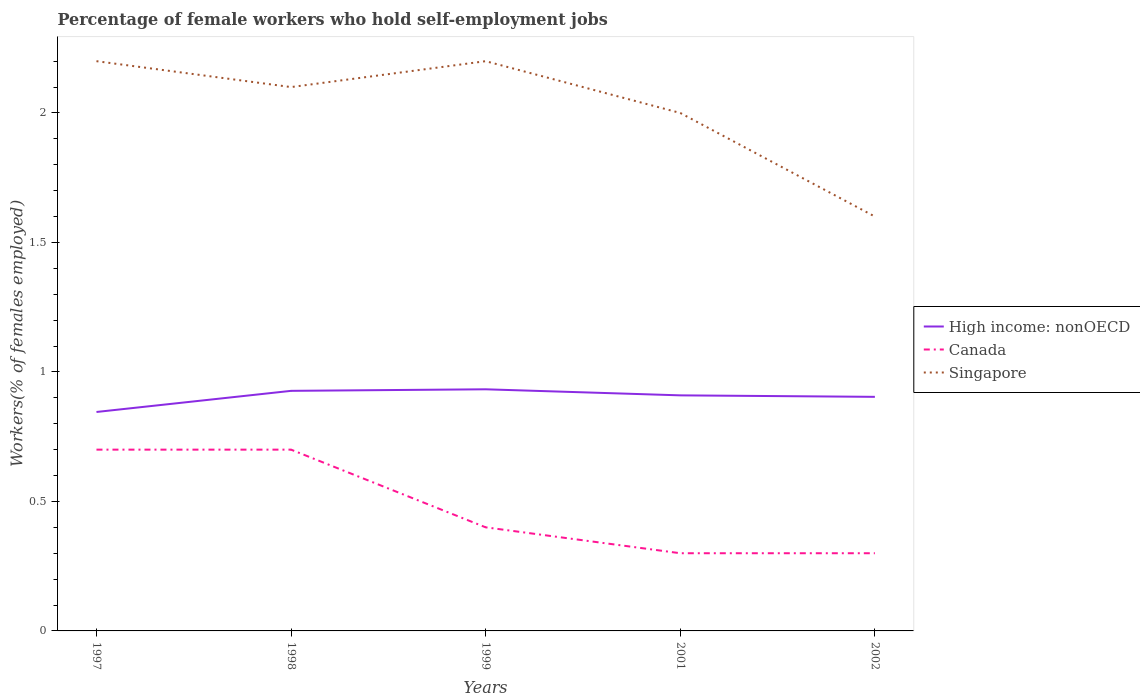How many different coloured lines are there?
Offer a terse response. 3. Does the line corresponding to Singapore intersect with the line corresponding to Canada?
Your answer should be compact. No. Across all years, what is the maximum percentage of self-employed female workers in High income: nonOECD?
Give a very brief answer. 0.85. What is the total percentage of self-employed female workers in Canada in the graph?
Give a very brief answer. 0.1. What is the difference between the highest and the second highest percentage of self-employed female workers in High income: nonOECD?
Your answer should be very brief. 0.09. How many lines are there?
Provide a succinct answer. 3. How many years are there in the graph?
Your answer should be very brief. 5. Does the graph contain grids?
Provide a succinct answer. No. Where does the legend appear in the graph?
Ensure brevity in your answer.  Center right. How many legend labels are there?
Offer a terse response. 3. What is the title of the graph?
Provide a succinct answer. Percentage of female workers who hold self-employment jobs. Does "Italy" appear as one of the legend labels in the graph?
Ensure brevity in your answer.  No. What is the label or title of the X-axis?
Provide a succinct answer. Years. What is the label or title of the Y-axis?
Your answer should be very brief. Workers(% of females employed). What is the Workers(% of females employed) in High income: nonOECD in 1997?
Your response must be concise. 0.85. What is the Workers(% of females employed) in Canada in 1997?
Your answer should be very brief. 0.7. What is the Workers(% of females employed) of Singapore in 1997?
Your answer should be very brief. 2.2. What is the Workers(% of females employed) in High income: nonOECD in 1998?
Make the answer very short. 0.93. What is the Workers(% of females employed) in Canada in 1998?
Provide a short and direct response. 0.7. What is the Workers(% of females employed) of Singapore in 1998?
Provide a succinct answer. 2.1. What is the Workers(% of females employed) of High income: nonOECD in 1999?
Your response must be concise. 0.93. What is the Workers(% of females employed) of Canada in 1999?
Give a very brief answer. 0.4. What is the Workers(% of females employed) of Singapore in 1999?
Provide a short and direct response. 2.2. What is the Workers(% of females employed) of High income: nonOECD in 2001?
Offer a very short reply. 0.91. What is the Workers(% of females employed) in Canada in 2001?
Give a very brief answer. 0.3. What is the Workers(% of females employed) of Singapore in 2001?
Provide a succinct answer. 2. What is the Workers(% of females employed) of High income: nonOECD in 2002?
Your response must be concise. 0.9. What is the Workers(% of females employed) of Canada in 2002?
Give a very brief answer. 0.3. What is the Workers(% of females employed) of Singapore in 2002?
Give a very brief answer. 1.6. Across all years, what is the maximum Workers(% of females employed) in High income: nonOECD?
Make the answer very short. 0.93. Across all years, what is the maximum Workers(% of females employed) of Canada?
Provide a short and direct response. 0.7. Across all years, what is the maximum Workers(% of females employed) of Singapore?
Provide a succinct answer. 2.2. Across all years, what is the minimum Workers(% of females employed) in High income: nonOECD?
Make the answer very short. 0.85. Across all years, what is the minimum Workers(% of females employed) in Canada?
Keep it short and to the point. 0.3. Across all years, what is the minimum Workers(% of females employed) of Singapore?
Your answer should be compact. 1.6. What is the total Workers(% of females employed) in High income: nonOECD in the graph?
Your answer should be compact. 4.52. What is the difference between the Workers(% of females employed) in High income: nonOECD in 1997 and that in 1998?
Your answer should be compact. -0.08. What is the difference between the Workers(% of females employed) of High income: nonOECD in 1997 and that in 1999?
Make the answer very short. -0.09. What is the difference between the Workers(% of females employed) of Canada in 1997 and that in 1999?
Keep it short and to the point. 0.3. What is the difference between the Workers(% of females employed) of Singapore in 1997 and that in 1999?
Ensure brevity in your answer.  0. What is the difference between the Workers(% of females employed) in High income: nonOECD in 1997 and that in 2001?
Keep it short and to the point. -0.06. What is the difference between the Workers(% of females employed) in Singapore in 1997 and that in 2001?
Your answer should be very brief. 0.2. What is the difference between the Workers(% of females employed) of High income: nonOECD in 1997 and that in 2002?
Your answer should be very brief. -0.06. What is the difference between the Workers(% of females employed) of Canada in 1997 and that in 2002?
Keep it short and to the point. 0.4. What is the difference between the Workers(% of females employed) in Singapore in 1997 and that in 2002?
Give a very brief answer. 0.6. What is the difference between the Workers(% of females employed) in High income: nonOECD in 1998 and that in 1999?
Your answer should be compact. -0.01. What is the difference between the Workers(% of females employed) in Canada in 1998 and that in 1999?
Offer a very short reply. 0.3. What is the difference between the Workers(% of females employed) of High income: nonOECD in 1998 and that in 2001?
Give a very brief answer. 0.02. What is the difference between the Workers(% of females employed) of Canada in 1998 and that in 2001?
Make the answer very short. 0.4. What is the difference between the Workers(% of females employed) in Singapore in 1998 and that in 2001?
Offer a terse response. 0.1. What is the difference between the Workers(% of females employed) of High income: nonOECD in 1998 and that in 2002?
Ensure brevity in your answer.  0.02. What is the difference between the Workers(% of females employed) of Canada in 1998 and that in 2002?
Offer a terse response. 0.4. What is the difference between the Workers(% of females employed) of Singapore in 1998 and that in 2002?
Your answer should be compact. 0.5. What is the difference between the Workers(% of females employed) in High income: nonOECD in 1999 and that in 2001?
Make the answer very short. 0.02. What is the difference between the Workers(% of females employed) in Canada in 1999 and that in 2001?
Make the answer very short. 0.1. What is the difference between the Workers(% of females employed) in High income: nonOECD in 1999 and that in 2002?
Give a very brief answer. 0.03. What is the difference between the Workers(% of females employed) of Canada in 1999 and that in 2002?
Ensure brevity in your answer.  0.1. What is the difference between the Workers(% of females employed) of Singapore in 1999 and that in 2002?
Provide a succinct answer. 0.6. What is the difference between the Workers(% of females employed) in High income: nonOECD in 2001 and that in 2002?
Offer a terse response. 0.01. What is the difference between the Workers(% of females employed) of High income: nonOECD in 1997 and the Workers(% of females employed) of Canada in 1998?
Give a very brief answer. 0.15. What is the difference between the Workers(% of females employed) of High income: nonOECD in 1997 and the Workers(% of females employed) of Singapore in 1998?
Your answer should be compact. -1.25. What is the difference between the Workers(% of females employed) in Canada in 1997 and the Workers(% of females employed) in Singapore in 1998?
Provide a short and direct response. -1.4. What is the difference between the Workers(% of females employed) in High income: nonOECD in 1997 and the Workers(% of females employed) in Canada in 1999?
Your answer should be very brief. 0.45. What is the difference between the Workers(% of females employed) of High income: nonOECD in 1997 and the Workers(% of females employed) of Singapore in 1999?
Give a very brief answer. -1.35. What is the difference between the Workers(% of females employed) in High income: nonOECD in 1997 and the Workers(% of females employed) in Canada in 2001?
Make the answer very short. 0.55. What is the difference between the Workers(% of females employed) in High income: nonOECD in 1997 and the Workers(% of females employed) in Singapore in 2001?
Provide a succinct answer. -1.15. What is the difference between the Workers(% of females employed) in High income: nonOECD in 1997 and the Workers(% of females employed) in Canada in 2002?
Provide a short and direct response. 0.55. What is the difference between the Workers(% of females employed) of High income: nonOECD in 1997 and the Workers(% of females employed) of Singapore in 2002?
Your answer should be very brief. -0.75. What is the difference between the Workers(% of females employed) of High income: nonOECD in 1998 and the Workers(% of females employed) of Canada in 1999?
Your answer should be compact. 0.53. What is the difference between the Workers(% of females employed) of High income: nonOECD in 1998 and the Workers(% of females employed) of Singapore in 1999?
Offer a very short reply. -1.27. What is the difference between the Workers(% of females employed) of Canada in 1998 and the Workers(% of females employed) of Singapore in 1999?
Provide a short and direct response. -1.5. What is the difference between the Workers(% of females employed) of High income: nonOECD in 1998 and the Workers(% of females employed) of Canada in 2001?
Make the answer very short. 0.63. What is the difference between the Workers(% of females employed) of High income: nonOECD in 1998 and the Workers(% of females employed) of Singapore in 2001?
Make the answer very short. -1.07. What is the difference between the Workers(% of females employed) of Canada in 1998 and the Workers(% of females employed) of Singapore in 2001?
Offer a terse response. -1.3. What is the difference between the Workers(% of females employed) in High income: nonOECD in 1998 and the Workers(% of females employed) in Canada in 2002?
Provide a short and direct response. 0.63. What is the difference between the Workers(% of females employed) in High income: nonOECD in 1998 and the Workers(% of females employed) in Singapore in 2002?
Offer a terse response. -0.67. What is the difference between the Workers(% of females employed) of High income: nonOECD in 1999 and the Workers(% of females employed) of Canada in 2001?
Offer a terse response. 0.63. What is the difference between the Workers(% of females employed) of High income: nonOECD in 1999 and the Workers(% of females employed) of Singapore in 2001?
Give a very brief answer. -1.07. What is the difference between the Workers(% of females employed) in Canada in 1999 and the Workers(% of females employed) in Singapore in 2001?
Provide a succinct answer. -1.6. What is the difference between the Workers(% of females employed) in High income: nonOECD in 1999 and the Workers(% of females employed) in Canada in 2002?
Provide a succinct answer. 0.63. What is the difference between the Workers(% of females employed) of High income: nonOECD in 1999 and the Workers(% of females employed) of Singapore in 2002?
Provide a short and direct response. -0.67. What is the difference between the Workers(% of females employed) in Canada in 1999 and the Workers(% of females employed) in Singapore in 2002?
Keep it short and to the point. -1.2. What is the difference between the Workers(% of females employed) in High income: nonOECD in 2001 and the Workers(% of females employed) in Canada in 2002?
Your answer should be very brief. 0.61. What is the difference between the Workers(% of females employed) of High income: nonOECD in 2001 and the Workers(% of females employed) of Singapore in 2002?
Offer a terse response. -0.69. What is the difference between the Workers(% of females employed) in Canada in 2001 and the Workers(% of females employed) in Singapore in 2002?
Provide a succinct answer. -1.3. What is the average Workers(% of females employed) of High income: nonOECD per year?
Keep it short and to the point. 0.9. What is the average Workers(% of females employed) of Canada per year?
Offer a very short reply. 0.48. What is the average Workers(% of females employed) of Singapore per year?
Ensure brevity in your answer.  2.02. In the year 1997, what is the difference between the Workers(% of females employed) of High income: nonOECD and Workers(% of females employed) of Canada?
Make the answer very short. 0.15. In the year 1997, what is the difference between the Workers(% of females employed) of High income: nonOECD and Workers(% of females employed) of Singapore?
Offer a terse response. -1.35. In the year 1998, what is the difference between the Workers(% of females employed) of High income: nonOECD and Workers(% of females employed) of Canada?
Make the answer very short. 0.23. In the year 1998, what is the difference between the Workers(% of females employed) in High income: nonOECD and Workers(% of females employed) in Singapore?
Offer a very short reply. -1.17. In the year 1999, what is the difference between the Workers(% of females employed) in High income: nonOECD and Workers(% of females employed) in Canada?
Provide a short and direct response. 0.53. In the year 1999, what is the difference between the Workers(% of females employed) of High income: nonOECD and Workers(% of females employed) of Singapore?
Make the answer very short. -1.27. In the year 2001, what is the difference between the Workers(% of females employed) of High income: nonOECD and Workers(% of females employed) of Canada?
Provide a short and direct response. 0.61. In the year 2001, what is the difference between the Workers(% of females employed) in High income: nonOECD and Workers(% of females employed) in Singapore?
Offer a terse response. -1.09. In the year 2002, what is the difference between the Workers(% of females employed) in High income: nonOECD and Workers(% of females employed) in Canada?
Offer a terse response. 0.6. In the year 2002, what is the difference between the Workers(% of females employed) in High income: nonOECD and Workers(% of females employed) in Singapore?
Provide a succinct answer. -0.7. In the year 2002, what is the difference between the Workers(% of females employed) in Canada and Workers(% of females employed) in Singapore?
Offer a very short reply. -1.3. What is the ratio of the Workers(% of females employed) in High income: nonOECD in 1997 to that in 1998?
Provide a short and direct response. 0.91. What is the ratio of the Workers(% of females employed) of Singapore in 1997 to that in 1998?
Give a very brief answer. 1.05. What is the ratio of the Workers(% of females employed) in High income: nonOECD in 1997 to that in 1999?
Offer a very short reply. 0.91. What is the ratio of the Workers(% of females employed) in Canada in 1997 to that in 1999?
Offer a very short reply. 1.75. What is the ratio of the Workers(% of females employed) of High income: nonOECD in 1997 to that in 2001?
Your answer should be compact. 0.93. What is the ratio of the Workers(% of females employed) in Canada in 1997 to that in 2001?
Offer a very short reply. 2.33. What is the ratio of the Workers(% of females employed) of Singapore in 1997 to that in 2001?
Provide a short and direct response. 1.1. What is the ratio of the Workers(% of females employed) of High income: nonOECD in 1997 to that in 2002?
Offer a terse response. 0.94. What is the ratio of the Workers(% of females employed) of Canada in 1997 to that in 2002?
Make the answer very short. 2.33. What is the ratio of the Workers(% of females employed) in Singapore in 1997 to that in 2002?
Your response must be concise. 1.38. What is the ratio of the Workers(% of females employed) in Singapore in 1998 to that in 1999?
Offer a terse response. 0.95. What is the ratio of the Workers(% of females employed) in High income: nonOECD in 1998 to that in 2001?
Offer a very short reply. 1.02. What is the ratio of the Workers(% of females employed) of Canada in 1998 to that in 2001?
Your response must be concise. 2.33. What is the ratio of the Workers(% of females employed) in High income: nonOECD in 1998 to that in 2002?
Keep it short and to the point. 1.03. What is the ratio of the Workers(% of females employed) in Canada in 1998 to that in 2002?
Keep it short and to the point. 2.33. What is the ratio of the Workers(% of females employed) of Singapore in 1998 to that in 2002?
Ensure brevity in your answer.  1.31. What is the ratio of the Workers(% of females employed) in High income: nonOECD in 1999 to that in 2001?
Your answer should be very brief. 1.03. What is the ratio of the Workers(% of females employed) of High income: nonOECD in 1999 to that in 2002?
Give a very brief answer. 1.03. What is the ratio of the Workers(% of females employed) of Singapore in 1999 to that in 2002?
Keep it short and to the point. 1.38. What is the ratio of the Workers(% of females employed) in High income: nonOECD in 2001 to that in 2002?
Keep it short and to the point. 1.01. What is the ratio of the Workers(% of females employed) of Canada in 2001 to that in 2002?
Your answer should be compact. 1. What is the ratio of the Workers(% of females employed) in Singapore in 2001 to that in 2002?
Provide a succinct answer. 1.25. What is the difference between the highest and the second highest Workers(% of females employed) of High income: nonOECD?
Offer a terse response. 0.01. What is the difference between the highest and the second highest Workers(% of females employed) in Singapore?
Offer a very short reply. 0. What is the difference between the highest and the lowest Workers(% of females employed) of High income: nonOECD?
Provide a short and direct response. 0.09. What is the difference between the highest and the lowest Workers(% of females employed) of Canada?
Provide a short and direct response. 0.4. 